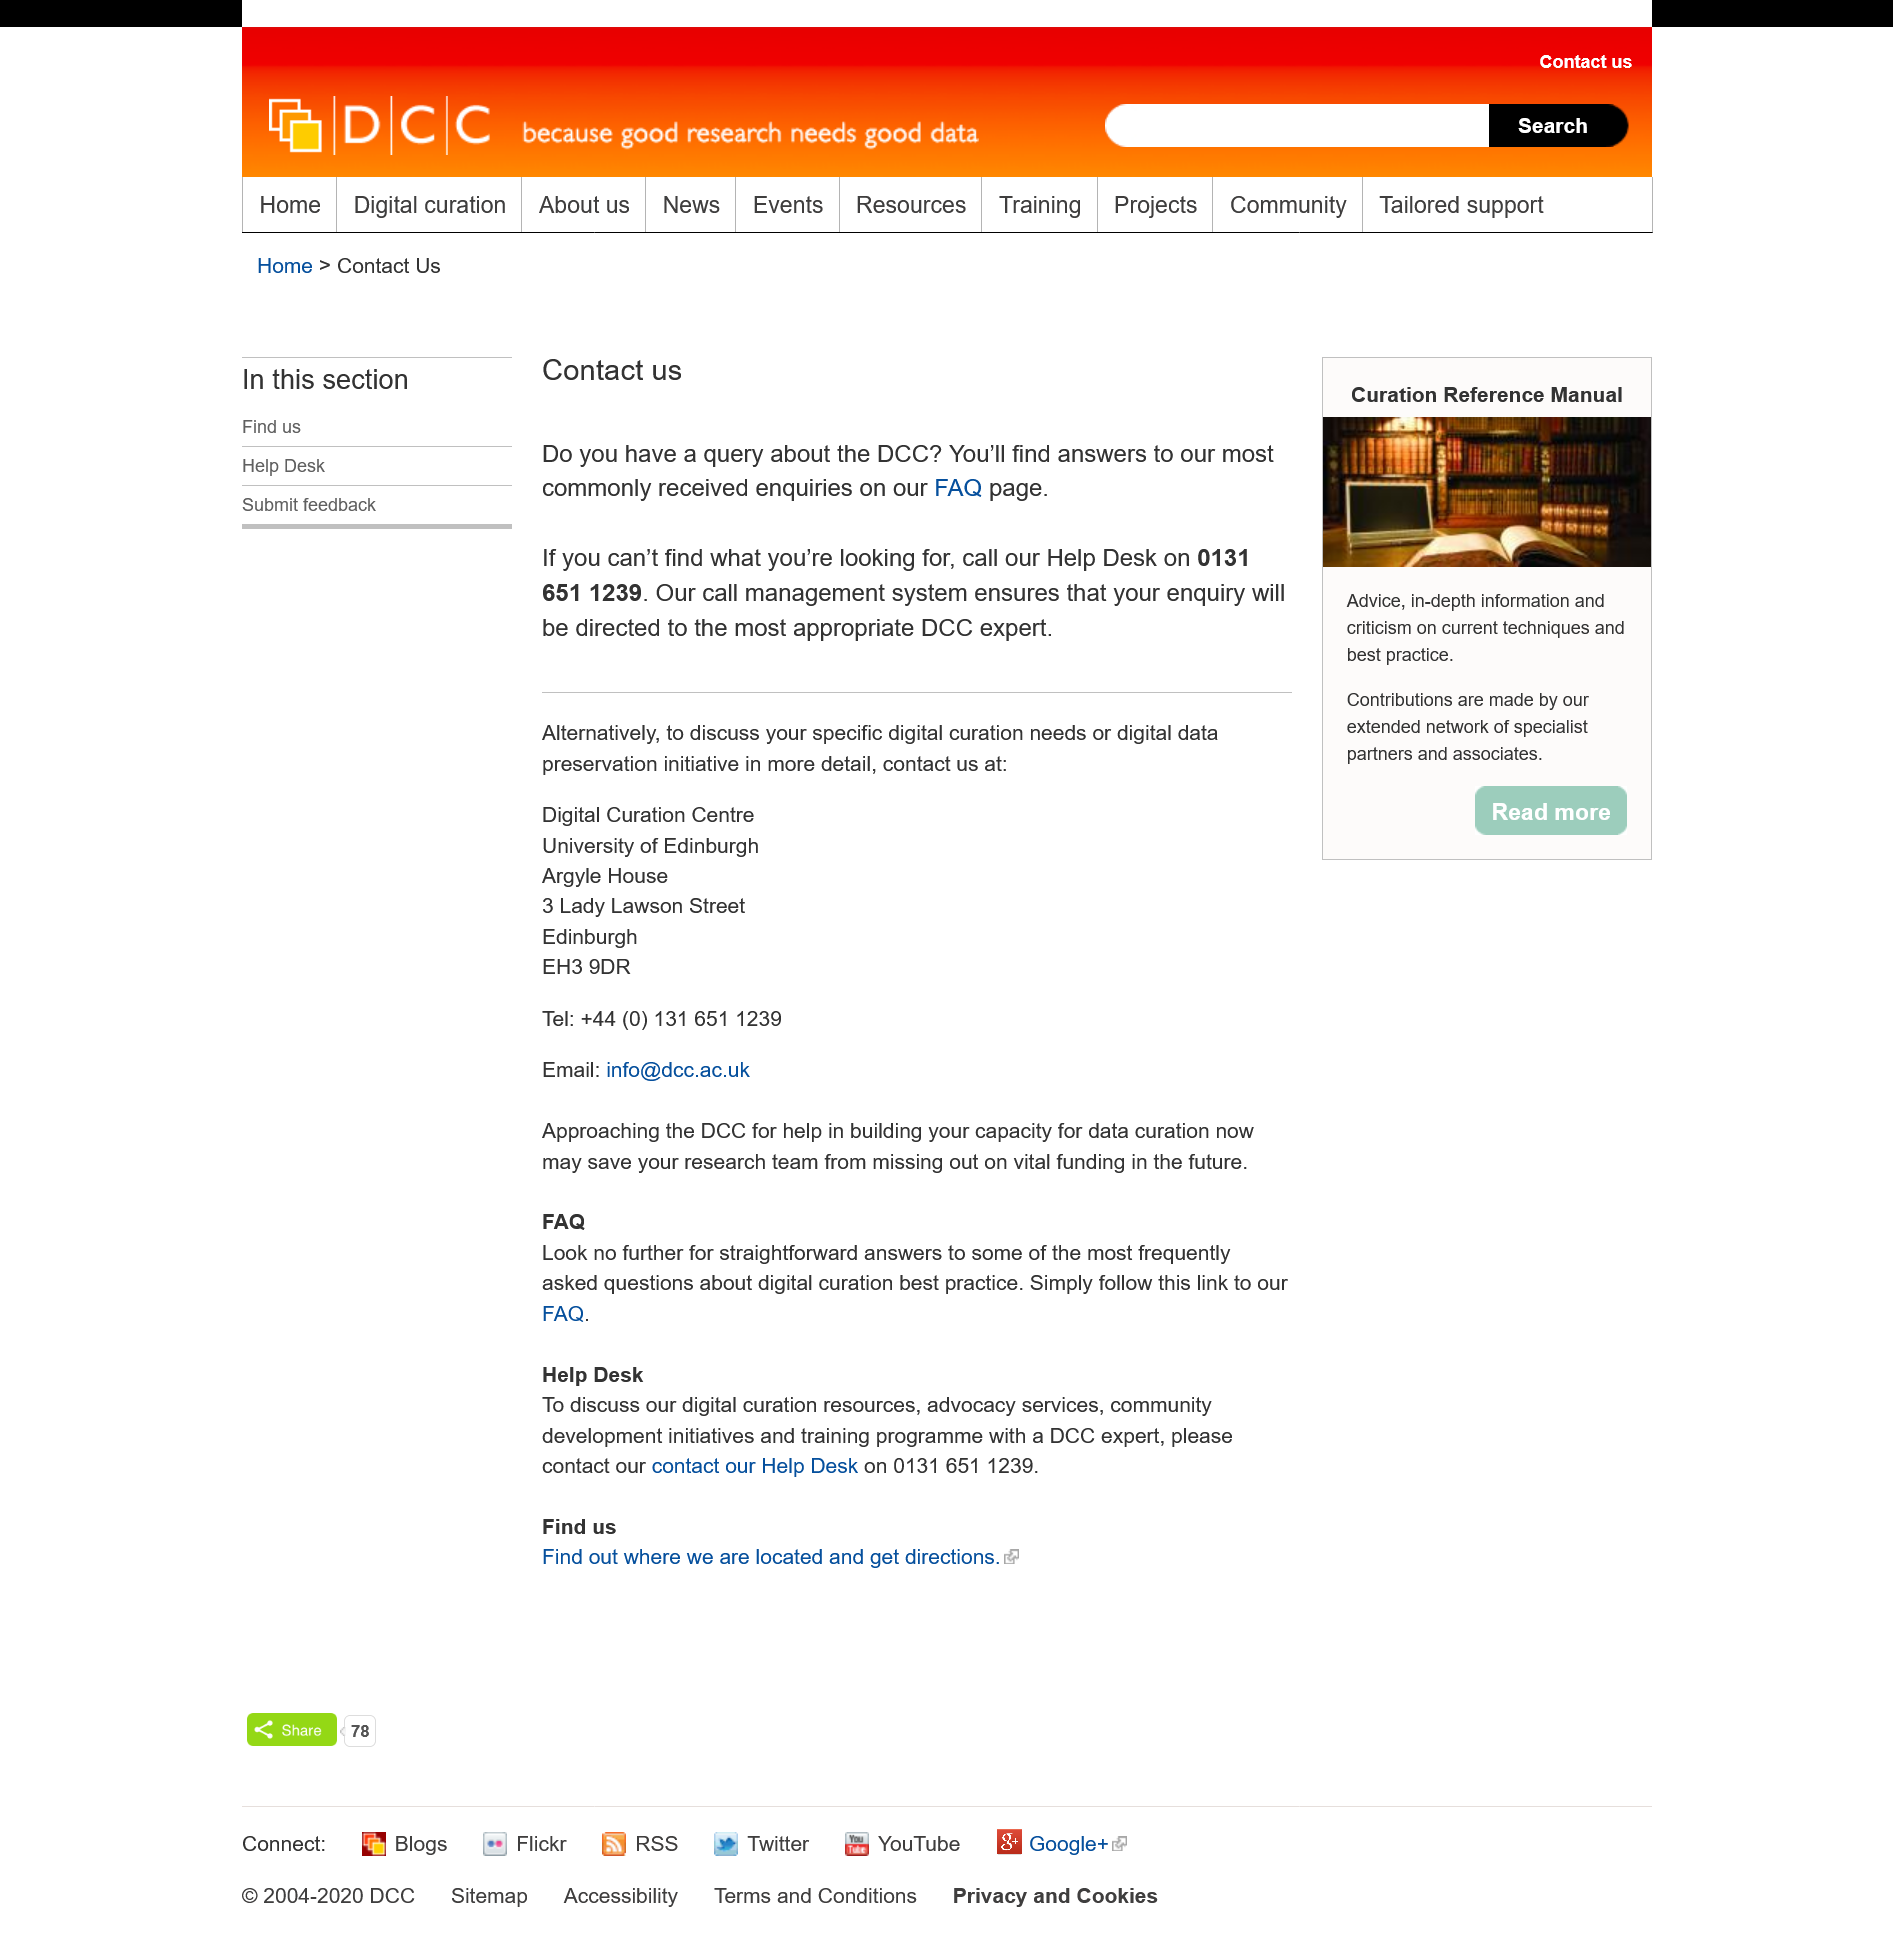Outline some significant characteristics in this image. It is determined that the enquiry will be answered by the most suitable DCC expert for the question. For access to a DCC expert, the help desk number is 0131 651 1239. The DCC provides answers to queries on its FAQ page, which can be accessed by searching for answers to queries about the DCC. 